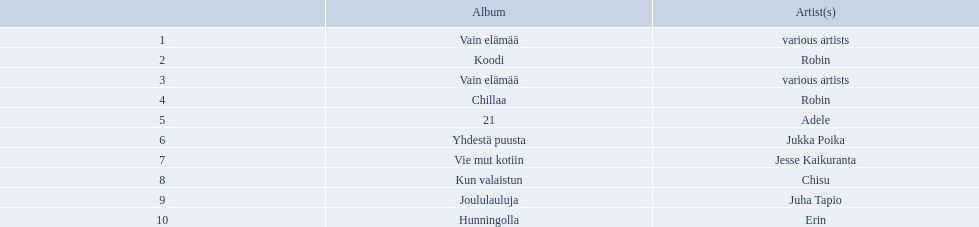Which artists' albums reached number one in finland during 2012? 164,119, 117,126, 81,725, 73,439, 44,297, 42,429, 38,985, 31,541, 29,080, 27,655. What were the sales figures of these albums? Various artists, robin, various artists, robin, adele, jukka poika, jesse kaikuranta, chisu, juha tapio, erin. And did adele or chisu have more sales during this period? Adele. Which were the number-one albums of 2012 in finland? Vain elämää, Koodi, Vain elämää, Chillaa, 21, Yhdestä puusta, Vie mut kotiin, Kun valaistun, Joululauluja, Hunningolla. Of those albums, which were by robin? Koodi, Chillaa. Of those albums by robin, which is not chillaa? Koodi. What are all the album titles? Vain elämää, Koodi, Vain elämää, Chillaa, 21, Yhdestä puusta, Vie mut kotiin, Kun valaistun, Joululauluja, Hunningolla. Which artists were on the albums? Various artists, robin, various artists, robin, adele, jukka poika, jesse kaikuranta, chisu, juha tapio, erin. Along with chillaa, which other album featured robin? Koodi. 